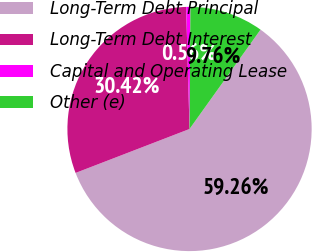Convert chart to OTSL. <chart><loc_0><loc_0><loc_500><loc_500><pie_chart><fcel>Long-Term Debt Principal<fcel>Long-Term Debt Interest<fcel>Capital and Operating Lease<fcel>Other (e)<nl><fcel>59.27%<fcel>30.42%<fcel>0.56%<fcel>9.76%<nl></chart> 